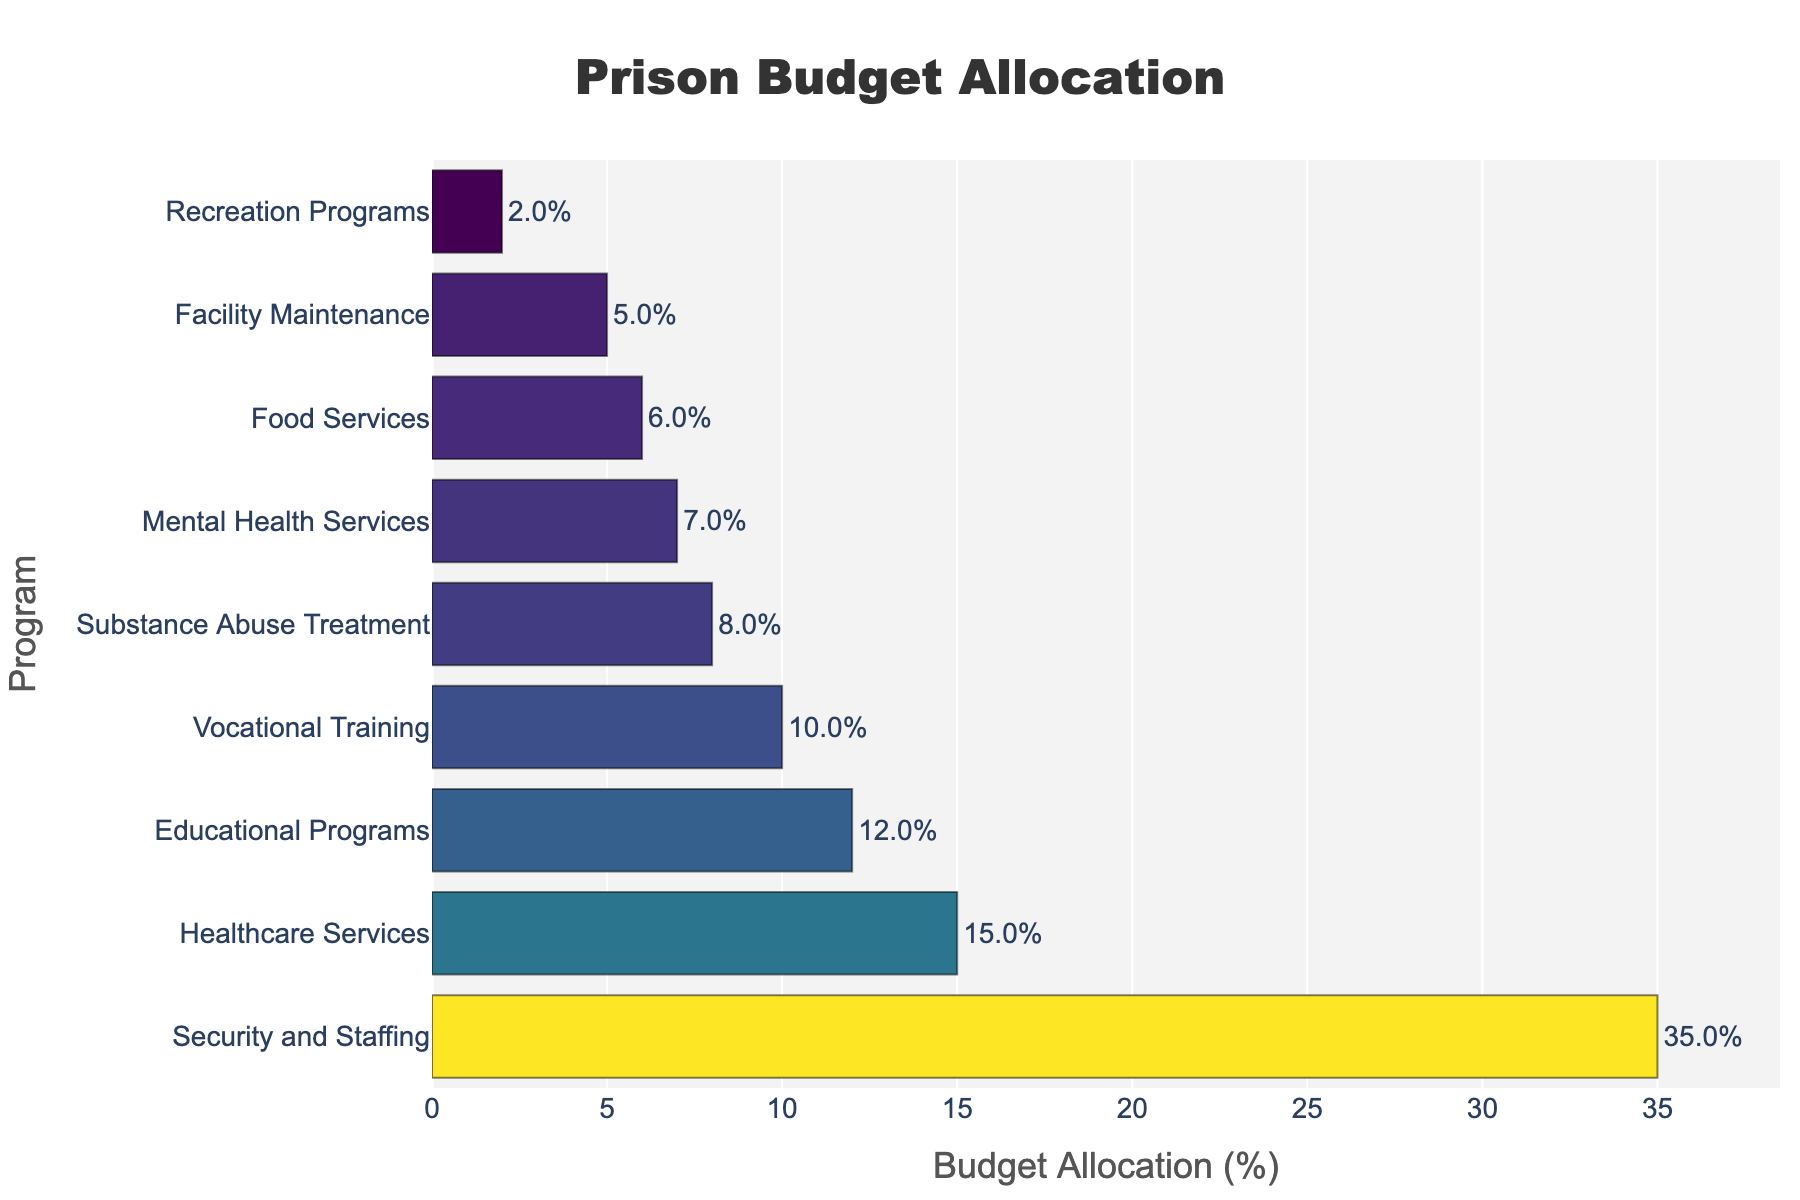Which program receives the highest budget allocation? The bar for "Security and Staffing" is the longest, indicating it has the highest budget allocation.
Answer: Security and Staffing Which programs have a budget allocation percentage greater than 10%? From the sorted bar lengths, "Security and Staffing," "Healthcare Services," "Educational Programs," and "Vocational Training" all have budget allocations greater than 10%.
Answer: Security and Staffing, Healthcare Services, Educational Programs, Vocational Training What is the total budget allocation percentage for all rehabilitation programs (Educational Programs, Vocational Training, Substance Abuse Treatment, Mental Health Services)? Adding the budget percentages for the mentioned programs: 12% + 10% + 8% + 7% = 37%.
Answer: 37% Which program has the lowest budget allocation, and what is the percentage? The smallest bar corresponds to "Recreation Programs," indicating it has the lowest budget allocation, which is 2%.
Answer: Recreation Programs, 2% What is the difference in budget allocation between Security and Staffing and Food Services? The bar length for "Security and Staffing" is 35%, and for "Food Services," it is 6%. The difference is 35% - 6% = 29%.
Answer: 29% How much more budget is allocated to Mental Health Services compared to Food Services? The bar for "Mental Health Services" shows 7%, and for "Food Services," it is 6%. The difference is 7% - 6% = 1%.
Answer: 1% Which program has exactly half the budget allocation of Security and Staffing? The budget allocation for "Security and Staffing" is 35%. Half of that is 35% / 2 = 17.5%. There is no program with exactly this value.
Answer: None What is the average budget allocation of Substance Abuse Treatment, Mental Health Services, and Food Services? The total of these is 8% + 7% + 6% = 21%. The average is 21% / 3 ≈ 7%.
Answer: 7% How do the allocations of Vocational Training and Educational Programs compare? The bar for "Vocational Training" is 10%, and "Educational Programs" is 12%. Vocational Training has a 2% lower allocation compared to Educational Programs.
Answer: Vocational Training is 2% lower What's the combined percentage for Food Services and Facility Maintenance? The bar lengths for "Food Services" and "Facility Maintenance" are 6% and 5%, respectively. Their combined total is 6% + 5% = 11%.
Answer: 11% 